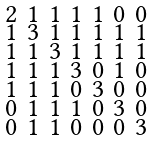<formula> <loc_0><loc_0><loc_500><loc_500>\begin{smallmatrix} 2 & 1 & 1 & 1 & 1 & 0 & 0 \\ 1 & 3 & 1 & 1 & 1 & 1 & 1 \\ 1 & 1 & 3 & 1 & 1 & 1 & 1 \\ 1 & 1 & 1 & 3 & 0 & 1 & 0 \\ 1 & 1 & 1 & 0 & 3 & 0 & 0 \\ 0 & 1 & 1 & 1 & 0 & 3 & 0 \\ 0 & 1 & 1 & 0 & 0 & 0 & 3 \end{smallmatrix}</formula> 